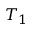<formula> <loc_0><loc_0><loc_500><loc_500>T _ { 1 }</formula> 